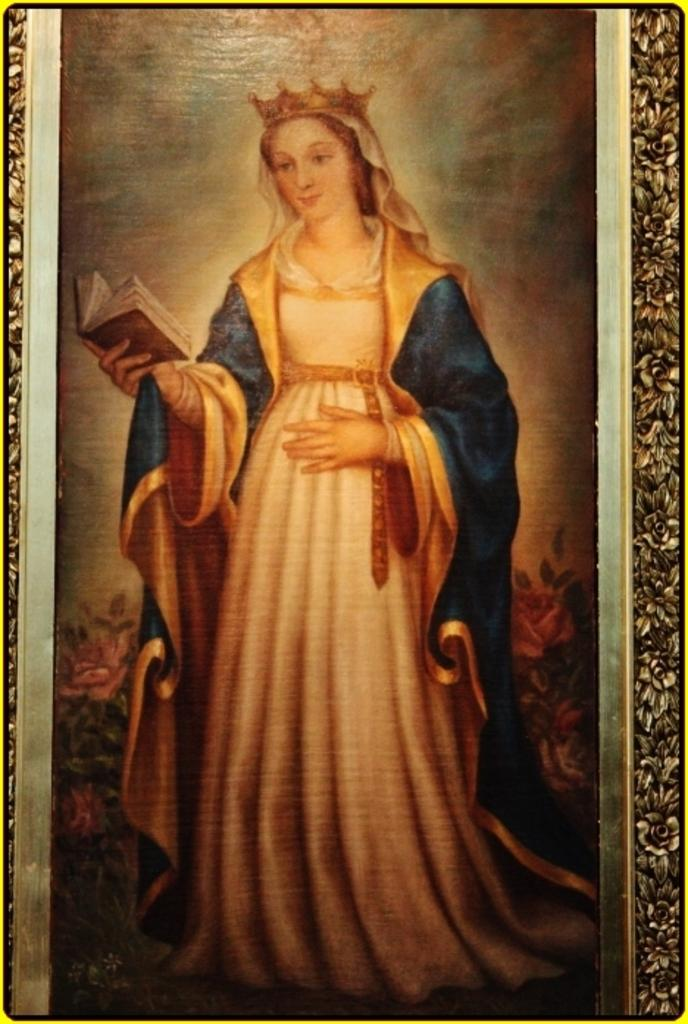Who or what is the main subject in the image? There is a person in the image. What is the person wearing? The person is wearing a crown. What is the person holding in the image? The person is holding a book with her hand. What type of net can be seen in the sky in the image? There is no net present in the image, nor is there any sky visible. 